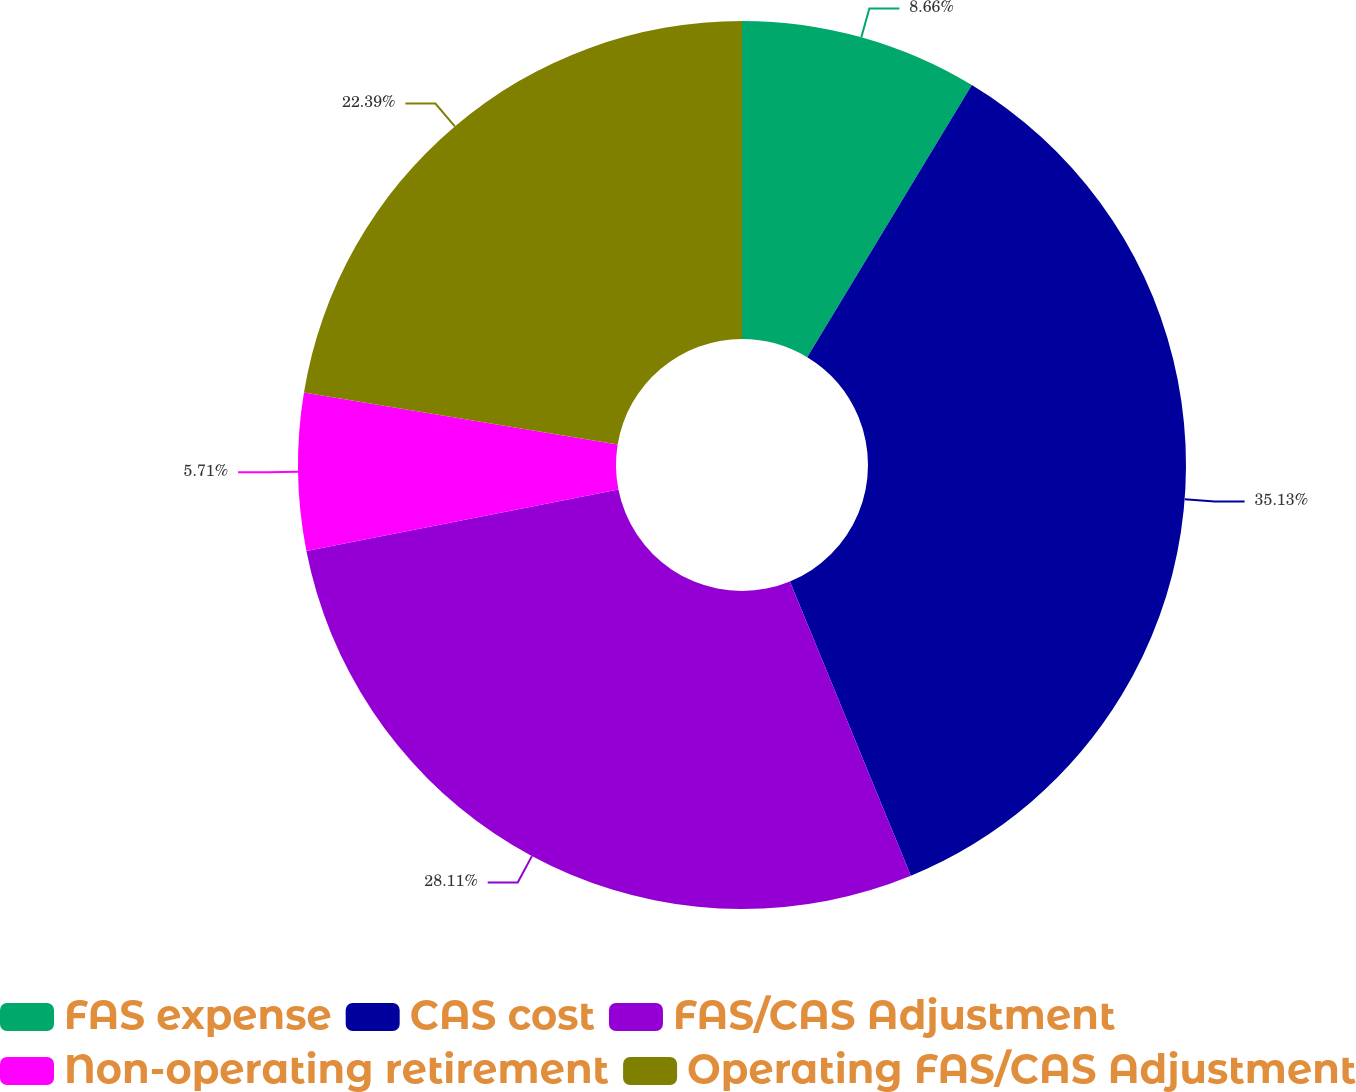<chart> <loc_0><loc_0><loc_500><loc_500><pie_chart><fcel>FAS expense<fcel>CAS cost<fcel>FAS/CAS Adjustment<fcel>Non-operating retirement<fcel>Operating FAS/CAS Adjustment<nl><fcel>8.66%<fcel>35.13%<fcel>28.11%<fcel>5.71%<fcel>22.39%<nl></chart> 